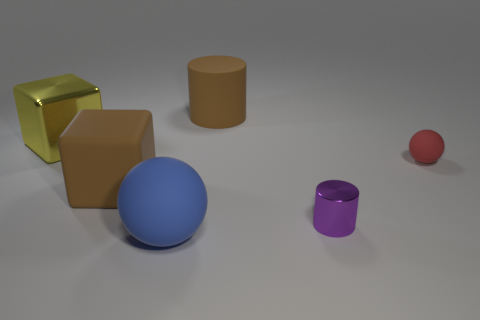Do the big brown cube and the block that is on the left side of the brown cube have the same material?
Make the answer very short. No. Are there fewer big rubber cylinders than matte objects?
Your response must be concise. Yes. Are there any other things that are the same color as the big matte cube?
Provide a short and direct response. Yes. There is a large blue object that is the same material as the brown cylinder; what is its shape?
Provide a succinct answer. Sphere. There is a large brown rubber object to the left of the object behind the large yellow shiny thing; what number of purple metallic cylinders are right of it?
Your answer should be very brief. 1. There is a big rubber object that is both in front of the small matte ball and behind the blue matte thing; what shape is it?
Provide a short and direct response. Cube. Are there fewer blue spheres on the right side of the brown cylinder than small rubber balls?
Offer a terse response. Yes. What number of large objects are either yellow spheres or purple shiny things?
Give a very brief answer. 0. How big is the blue sphere?
Make the answer very short. Large. How many cylinders are in front of the red matte thing?
Your answer should be compact. 1. 